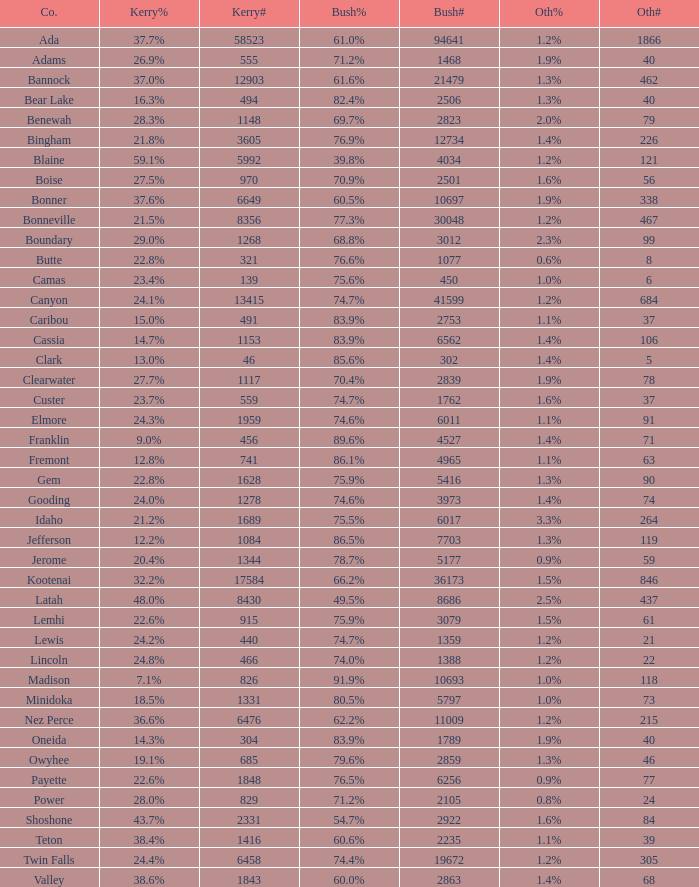How many different counts of the votes for Bush are there in the county where he got 69.7% of the votes? 1.0. 